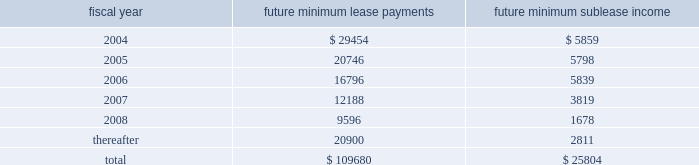Remarketing proceeds and the lease balance , up to the maximum recourse amount of $ 90.8 million ( 201cresidual value guarantee 201d ) .
In august 1999 , we entered into a five-year lease agreement for our other two office buildings that currently serve as our corporate headquarters in san jose , california .
Under the agreement , we have the option to purchase the buildings at any time during the lease term for the lease balance , which is approximately $ 142.5 million .
The lease is subject to standard covenants including liquidity , leverage and profitability ratios that are reported to the lessor quarterly .
As of november 28 , 2003 , we were in compliance with all covenants .
In the case of a default , the lessor may demand we purchase the buildings for an amount equal to the lease balance , or require that we remarket or relinquish the buildings .
The agreement qualifies for operating lease accounting treatment under sfas 13 and , as such , the buildings and the related obligation are not included on our balance sheet .
We utilized this type of financing because it allows us to access bank-provided funding at the most favorable rates and allows us to maintain our cash balances for other corporate purposes .
At the end of the lease term , we can purchase the buildings for the lease balance , remarket or relinquish the buildings .
If we choose to remarket or are required to do so upon relinquishing the buildings , we are bound to arrange the sale of the buildings to an unrelated party and will be required to pay the lessor any shortfall between the net remarketing proceeds and the lease balance , up to the maximum recourse amount of $ 132.6 million ( 201cresidual value guarantee 201d ) .
There were no changes in the agreement or level of obligations from the end of fiscal 2002 .
We are in the process of evaluating alternative financing methods at expiration of the lease in fiscal 2004 and believe that several suitable financing options will be available to us .
As of november 28 , 2003 , future minimum lease payments under noncancelable operating leases and future minimum sublease income under noncancelable subleases are as follows : fiscal year future minimum lease payments future minimum sublease income .
Royalties we have certain royalty commitments associated with the shipment and licensing of certain products .
Royalty expense is generally based on a dollar amount per unit shipped or a percentage of the underlying revenue .
Royalty expense , which was recorded under our cost of products revenue on our consolidated statements of income , was approximately $ 14.5 million , $ 14.4 million and $ 14.1 million in fiscal 2003 , 2002 and 2001 , respectively .
Guarantees we adopted fin 45 at the beginning of our fiscal year 2003 .
See 201cguarantees 201d and 201crecent accounting pronouncements 201d in note 1 of our notes to consolidated financial statements for further information regarding fin 45 .
Legal actions in early 2002 , international typeface corporation ( 201citc 201d ) and agfa monotype corporation ( 201camt 201d ) , companies which have common ownership and management , each charged , by way of informal letters to adobe , that adobe's distribution of font software , which generates itc and amt typefaces , breaches its contracts with itc and amt , respectively , pursuant to which adobe licensed certain rights with respect to itc and amt typefaces .
Amt and itc further charged that adobe violated the digital millennium copyright act ( 201cdmca 201d ) with respect to , or induced or contributed to , the infringement of copyrights in , itc 2019s and amt's truetype font software. .
What is the net cash outflow related to future lease payments in 2004? 
Computations: (29454 - 5859)
Answer: 23595.0. 